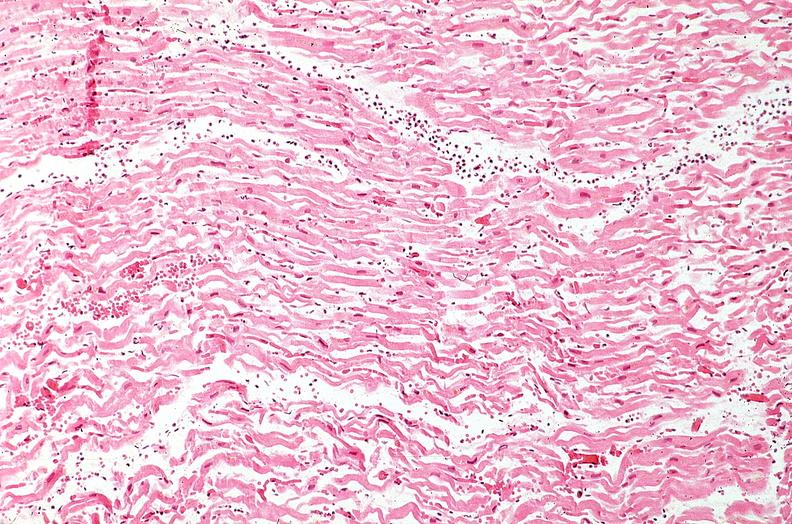does vasculature show heart, myocardial infarction, wavey fiber change, necrtosis, hemorrhage, and dissection?
Answer the question using a single word or phrase. No 